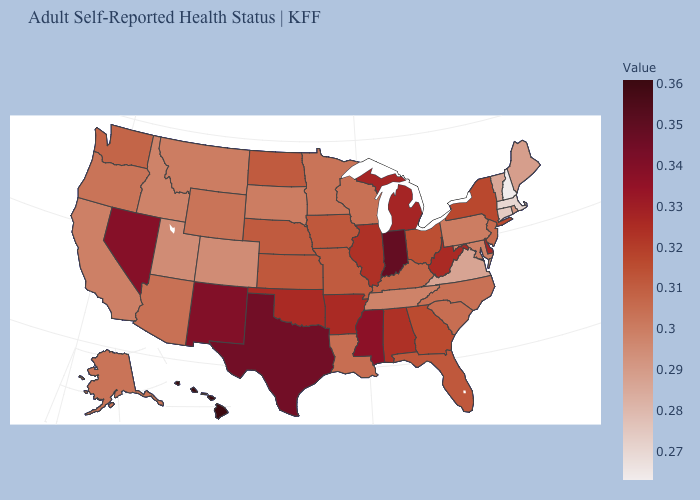Does Maryland have a lower value than Ohio?
Answer briefly. Yes. Which states have the lowest value in the USA?
Give a very brief answer. New Hampshire. Which states hav the highest value in the South?
Answer briefly. Texas. Which states have the highest value in the USA?
Answer briefly. Hawaii. 